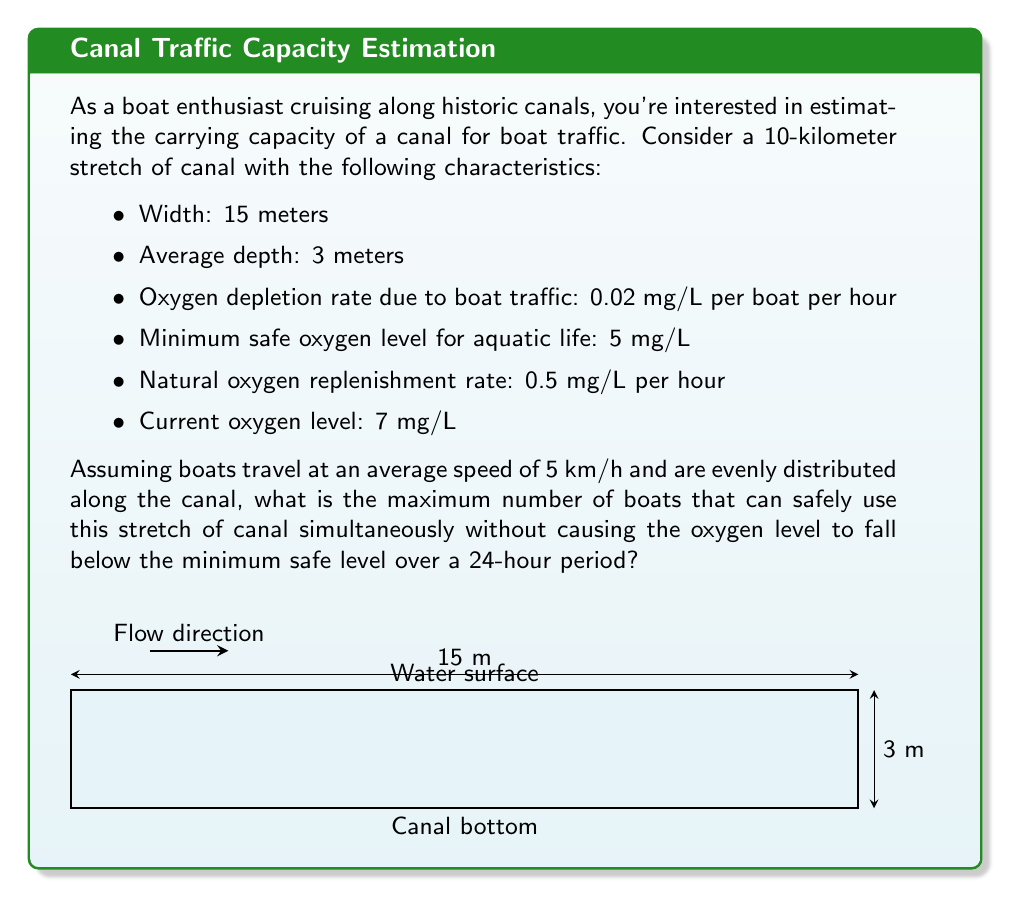What is the answer to this math problem? Let's approach this problem step-by-step:

1) First, we need to calculate the volume of water in the canal stretch:
   $$V = \text{length} \times \text{width} \times \text{depth}$$
   $$V = 10,000 \text{ m} \times 15 \text{ m} \times 3 \text{ m} = 450,000 \text{ m}^3$$

2) The time a boat spends in this stretch:
   $$t = \frac{\text{distance}}{\text{speed}} = \frac{10 \text{ km}}{5 \text{ km/h}} = 2 \text{ hours}$$

3) Let $x$ be the number of boats. The oxygen depletion over 24 hours due to boat traffic:
   $$\text{Depletion} = 0.02 \text{ mg/L/h} \times x \text{ boats} \times 24 \text{ h} = 0.48x \text{ mg/L}$$

4) Natural oxygen replenishment over 24 hours:
   $$\text{Replenishment} = 0.5 \text{ mg/L/h} \times 24 \text{ h} = 12 \text{ mg/L}$$

5) The oxygen balance equation:
   $$7 \text{ mg/L} + 12 \text{ mg/L} - 0.48x \text{ mg/L} \geq 5 \text{ mg/L}$$

6) Solving for $x$:
   $$14 \text{ mg/L} - 0.48x \text{ mg/L} \geq 5 \text{ mg/L}$$
   $$9 \text{ mg/L} \geq 0.48x \text{ mg/L}$$
   $$x \leq \frac{9}{0.48} \approx 18.75$$

7) Since we can't have a fraction of a boat, we round down to the nearest whole number.

Therefore, the maximum number of boats that can safely use this stretch of canal simultaneously is 18.
Answer: 18 boats 